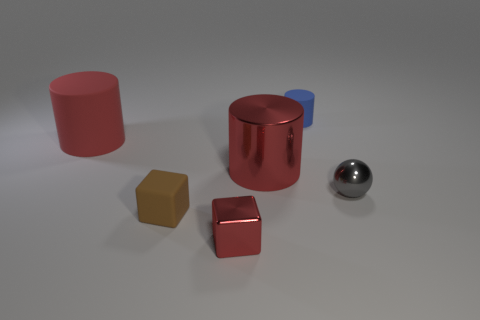Add 2 brown matte things. How many objects exist? 8 Subtract all cubes. How many objects are left? 4 Add 1 blue objects. How many blue objects exist? 2 Subtract 0 green cubes. How many objects are left? 6 Subtract all red blocks. Subtract all tiny balls. How many objects are left? 4 Add 5 gray balls. How many gray balls are left? 6 